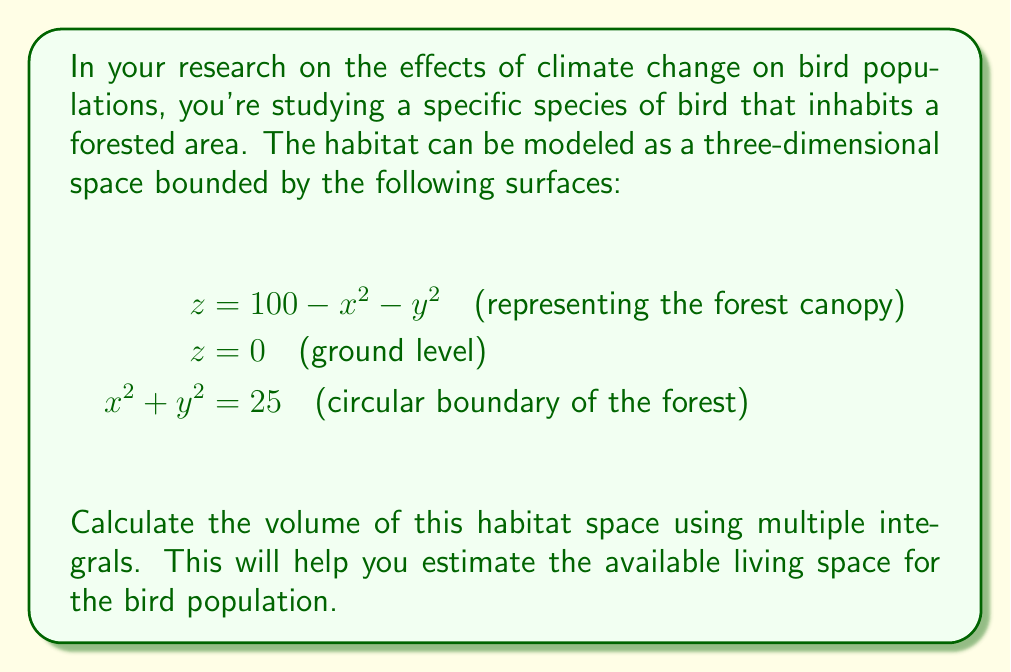Could you help me with this problem? To calculate the volume of this three-dimensional habitat space, we need to set up and evaluate a triple integral. Let's approach this step-by-step:

1) First, we need to determine the limits of integration. From the given equations:
   - The habitat is circular in the xy-plane with radius 5 (from $x^2 + y^2 = 25$)
   - The height varies from z = 0 to z = 100 - x^2 - y^2

2) Due to the circular base, it's best to use cylindrical coordinates:
   $x = r \cos(\theta)$, $y = r \sin(\theta)$, $z = z$

3) The volume integral in cylindrical coordinates is:

   $$V = \int_0^{2\pi} \int_0^5 \int_0^{100-r^2} r \, dz \, dr \, d\theta$$

4) Let's evaluate the integral from inside out:

   $$V = \int_0^{2\pi} \int_0^5 r(100-r^2) \, dr \, d\theta$$

5) Integrate with respect to r:

   $$V = \int_0^{2\pi} \left[50r^2 - \frac{r^4}{4}\right]_0^5 \, d\theta$$

6) Evaluate the inner integral:

   $$V = \int_0^{2\pi} \left(1250 - \frac{625}{4}\right) \, d\theta = \int_0^{2\pi} \frac{3750}{4} \, d\theta$$

7) Finally, integrate with respect to θ:

   $$V = \frac{3750}{4} \cdot 2\pi = \frac{3750\pi}{2}$$

Thus, the volume of the habitat space is $\frac{3750\pi}{2}$ cubic units.
Answer: $$\frac{3750\pi}{2}$$ cubic units 